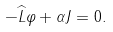<formula> <loc_0><loc_0><loc_500><loc_500>- \widehat { L } \varphi + \alpha J = 0 .</formula> 